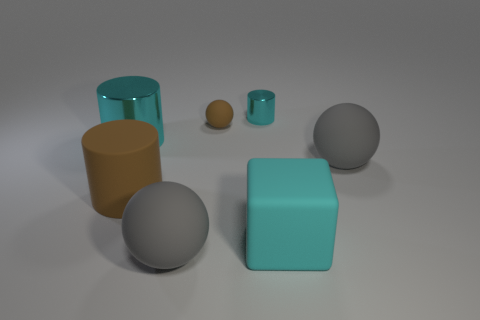Add 2 small cyan metal cylinders. How many objects exist? 9 Subtract all balls. How many objects are left? 4 Subtract 0 purple cylinders. How many objects are left? 7 Subtract all big cyan objects. Subtract all tiny balls. How many objects are left? 4 Add 7 cyan metallic cylinders. How many cyan metallic cylinders are left? 9 Add 5 tiny cyan cylinders. How many tiny cyan cylinders exist? 6 